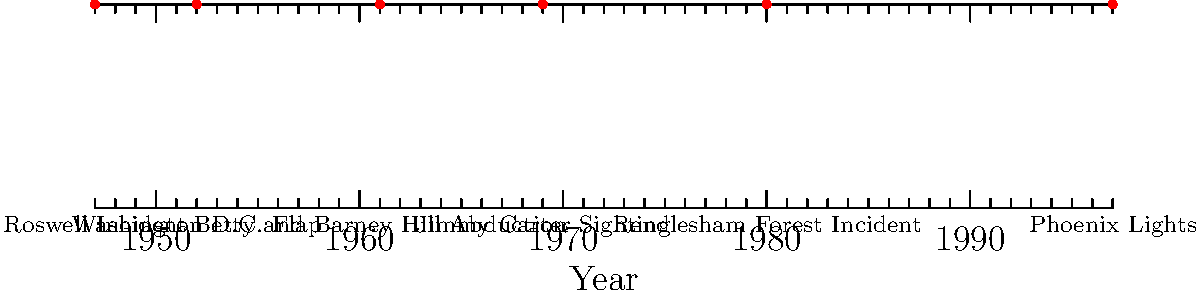Based on the timeline of major UFO sightings, which incident occurred closest to the midpoint between the Roswell Incident and the Phoenix Lights? To solve this problem, we need to follow these steps:

1. Identify the years of the Roswell Incident and Phoenix Lights:
   Roswell Incident: 1947
   Phoenix Lights: 1997

2. Calculate the midpoint between these two events:
   Midpoint = (1947 + 1997) / 2 = 1972

3. Compare the years of the other events to 1972:
   - Washington D.C. Flap: 1952 (20 years before midpoint)
   - Betty and Barney Hill Abduction: 1961 (11 years before midpoint)
   - Jimmy Carter Sighting: 1969 (3 years before midpoint)
   - Rendlesham Forest Incident: 1980 (8 years after midpoint)

4. Determine which event is closest to 1972:
   The Jimmy Carter Sighting in 1969 is closest, being only 3 years away from the midpoint.
Answer: Jimmy Carter Sighting 